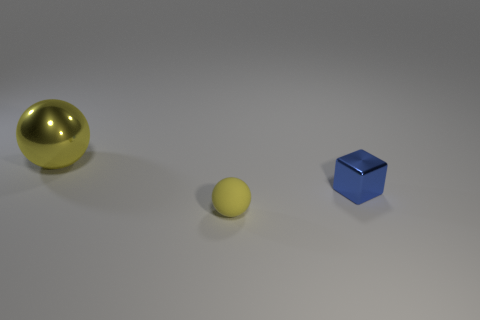Are there fewer metal cubes that are left of the tiny blue block than big rubber cylinders?
Give a very brief answer. No. There is a tiny object in front of the blue block; is it the same color as the large thing?
Offer a very short reply. Yes. How many shiny things are either small yellow spheres or big yellow cubes?
Provide a short and direct response. 0. Are there any other things that have the same size as the yellow metallic thing?
Provide a short and direct response. No. What color is the other object that is made of the same material as the large object?
Your answer should be compact. Blue. How many cylinders are either blue metallic things or large yellow metal things?
Make the answer very short. 0. What number of objects are metallic blocks or balls that are behind the tiny ball?
Your response must be concise. 2. Are any tiny yellow cubes visible?
Ensure brevity in your answer.  No. How many large metallic spheres have the same color as the small cube?
Your response must be concise. 0. There is another sphere that is the same color as the matte ball; what material is it?
Provide a short and direct response. Metal. 